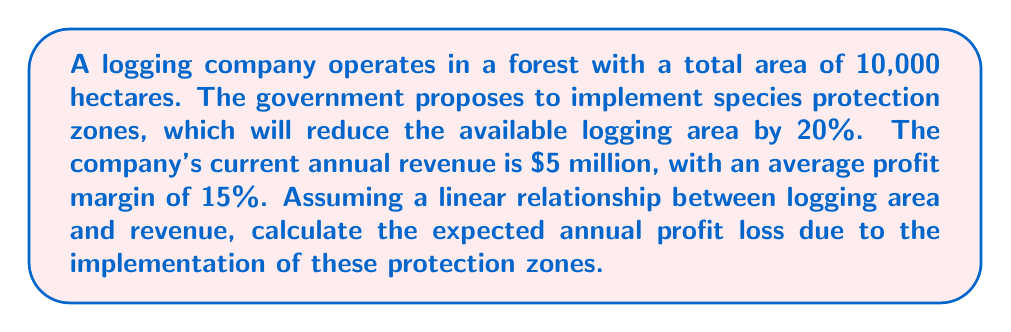Give your solution to this math problem. 1. Calculate the reduction in logging area:
   $20\% \text{ of } 10,000 \text{ hectares} = 0.20 \times 10,000 = 2,000 \text{ hectares}$

2. Calculate the percentage of remaining logging area:
   $\frac{10,000 - 2,000}{10,000} \times 100\% = 80\%$

3. Assuming a linear relationship, the new revenue will be 80% of the current revenue:
   $\text{New Revenue} = 80\% \times \$5,000,000 = \$4,000,000$

4. Calculate the current annual profit:
   $\text{Current Profit} = 15\% \times \$5,000,000 = \$750,000$

5. Calculate the new annual profit:
   $\text{New Profit} = 15\% \times \$4,000,000 = \$600,000$

6. Calculate the annual profit loss:
   $\text{Profit Loss} = \$750,000 - \$600,000 = \$150,000$

Therefore, the expected annual profit loss due to the implementation of species protection zones is $150,000.
Answer: $150,000 